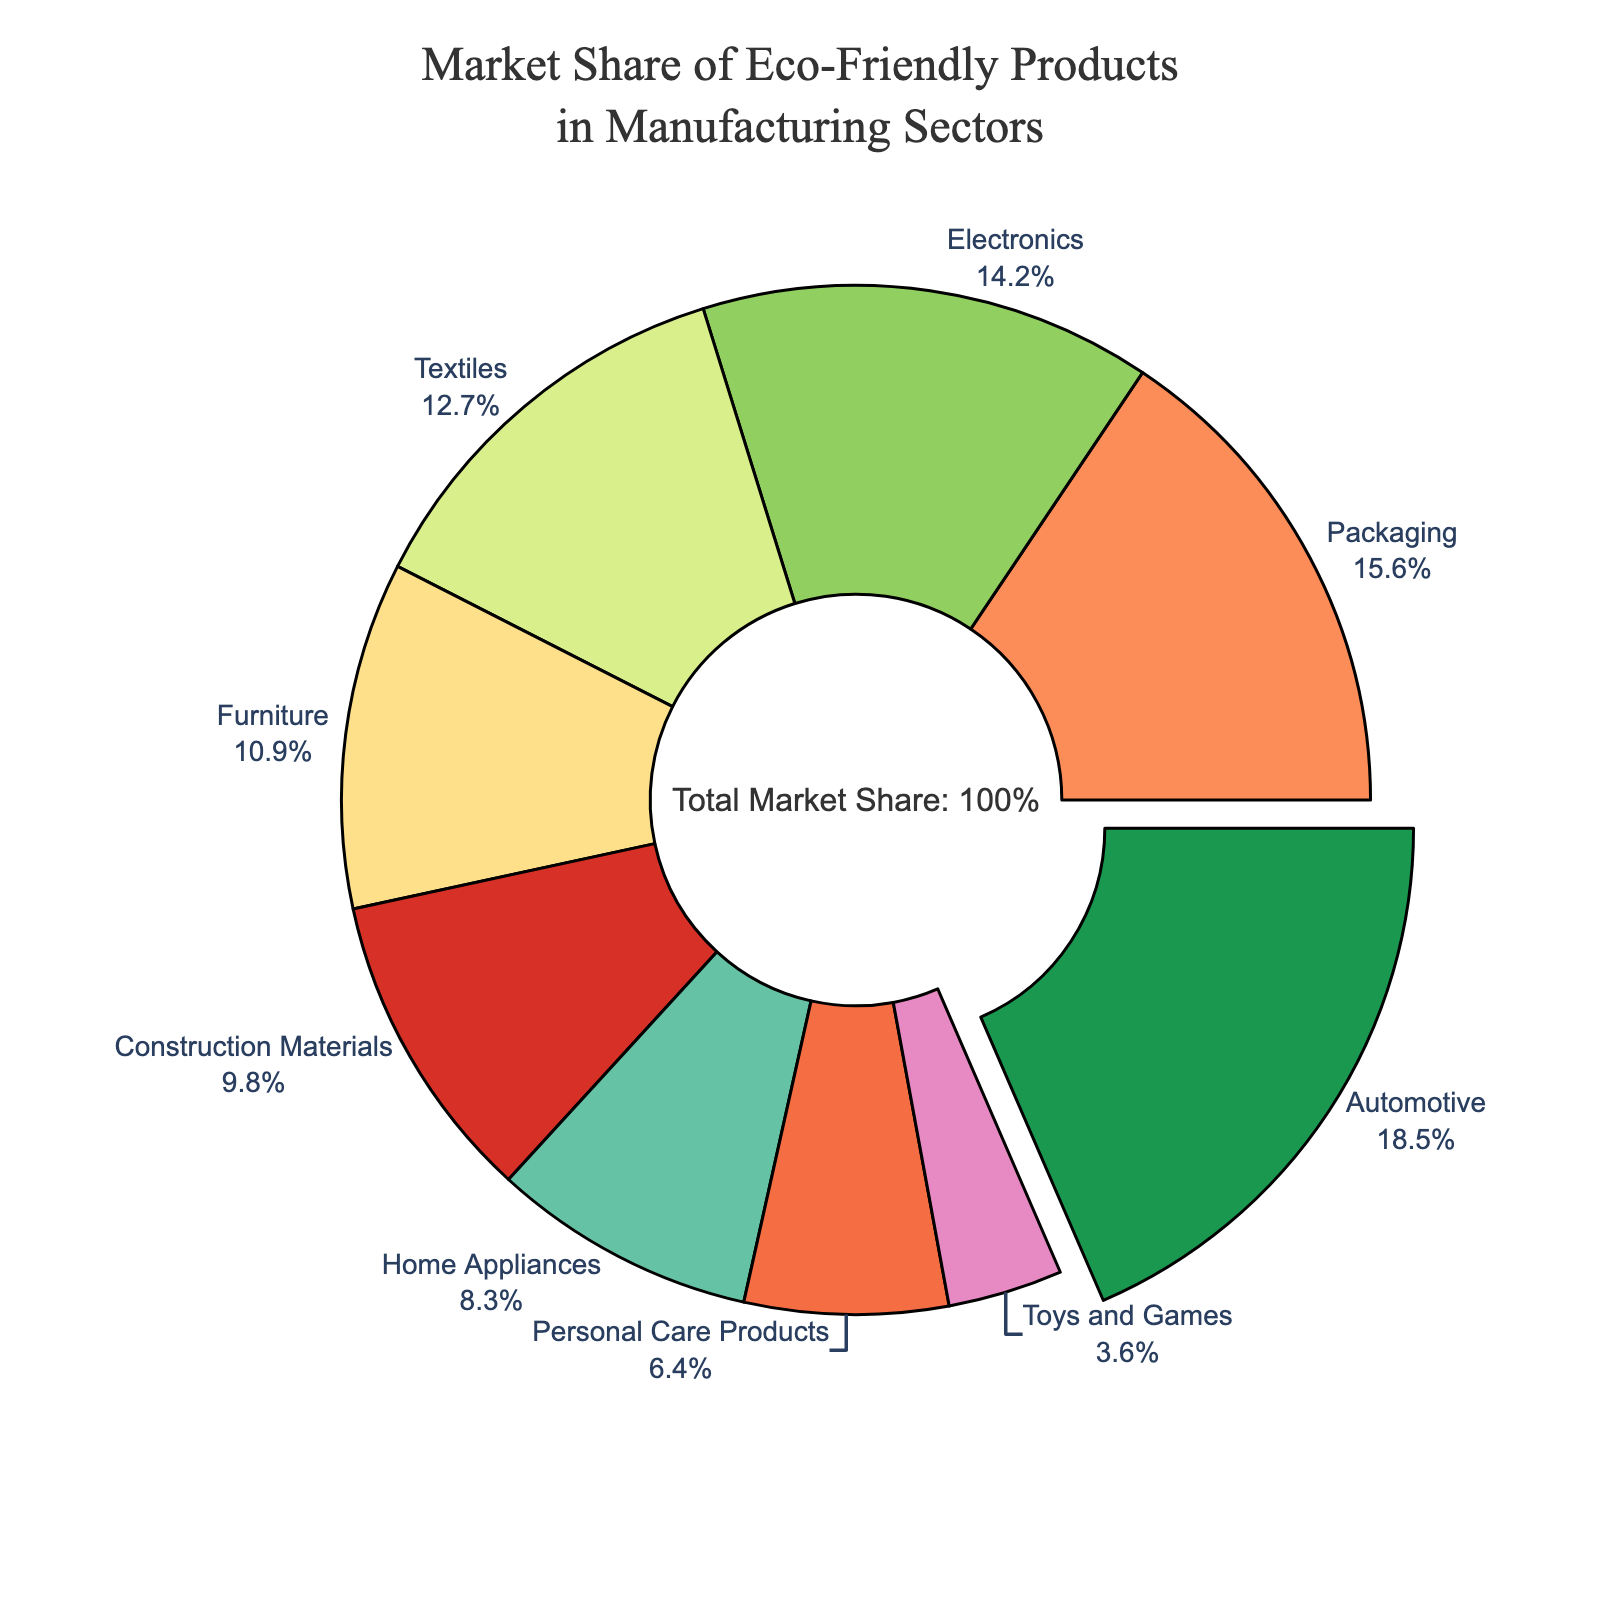What sector has the highest market share of eco-friendly products? The sector with the highest market share is the one with the largest slice of the pie chart and the pulled-out segment. The "Automotive" sector has the highest market share of 18.5%.
Answer: Automotive Which sector has a lower market share: Textiles or Furniture? To determine which sector has a lower market share, we look at the slices of the pie chart for both sectors. The "Textiles" sector has a market share of 12.7%, and the "Furniture" sector has a market share of 10.9%. 10.9% is less than 12.7%.
Answer: Furniture What is the total market share for the Electronics and Packaging sectors combined? To find the total market share of the Electronics and Packaging sectors, sum their individual values: Electronics (14.2%) + Packaging (15.6%) = 14.2% + 15.6% = 29.8%.
Answer: 29.8% Which sector's slice is represented by the color green? Observing the color code mentioned, green is used to depict one of the sectors. The first color in the custom palette is green, which corresponds to the Automotive sector, which has the largest market share and is also highlighted.
Answer: Automotive Is the market share of Home Appliances greater than that of Personal Care Products? To determine this, we compare the market shares of Home Appliances (8.3%) and Personal Care Products (6.4%). 8.3% is indeed greater than 6.4%.
Answer: Yes What are the sectors with the two smallest market shares and their combined percentage? Identifying the smallest slices, Toys and Games (3.6%) and Personal Care Products (6.4%) are the smallest sectors. Adding them together: 3.6% + 6.4% = 10%.
Answer: Toys and Games, Personal Care Products; 10% What is the difference in market share between the Automotive and the Construction Materials sectors? The market share of the Automotive sector is 18.5% and for Construction Materials is 9.8%. The difference is 18.5% - 9.8% = 8.7%.
Answer: 8.7% By observing the visual attributes, which sector has a thicker border compared to its slice's color fill? Every sector slice has a thick black border, making it prominent. Visually, this uniformity applies to all sectors due to the market-specific marker styling, so no sector specifically stands out by border thickness alone.
Answer: All sectors equally If all the sectors other than Electronics and Textiles were grouped together, what would their combined market share be? Summing the market shares of all the sectors except Electronics (14.2%) and Textiles (12.7%): 18.5% + 10.9% + 15.6% + 9.8% + 8.3% + 6.4% + 3.6% = 73.1%.
Answer: 73.1% Which two sectors combined have a market share closest to the Automotive sector? Finding close combinations: Electronics and Textiles = 14.2% + 12.7% = 26.9%, Electronics and Packaging = 14.2% + 15.6% = 29.8%, Textiles and Packaging = 12.7% + 15.6% = 28.3%. Comparing, the closest is Textiles and Packaging = 28.3%.
Answer: Textiles and Packaging 